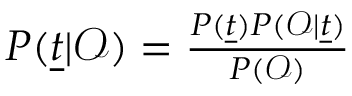Convert formula to latex. <formula><loc_0><loc_0><loc_500><loc_500>\begin{array} { r } { P ( \underline { t } | \mathcal { O } ) = \frac { P ( \underline { t } ) P ( \mathcal { O } | \underline { t } ) } { P ( \mathcal { O } ) } } \end{array}</formula> 